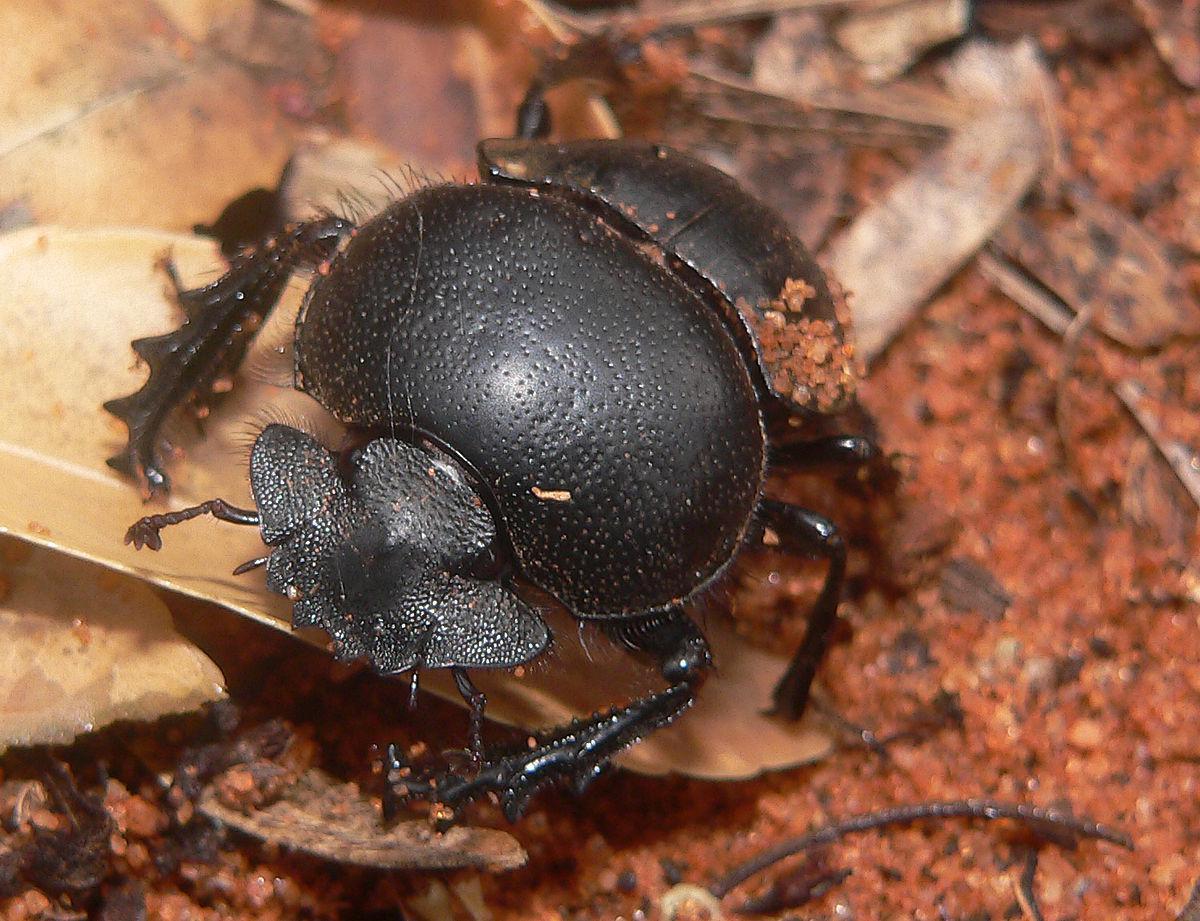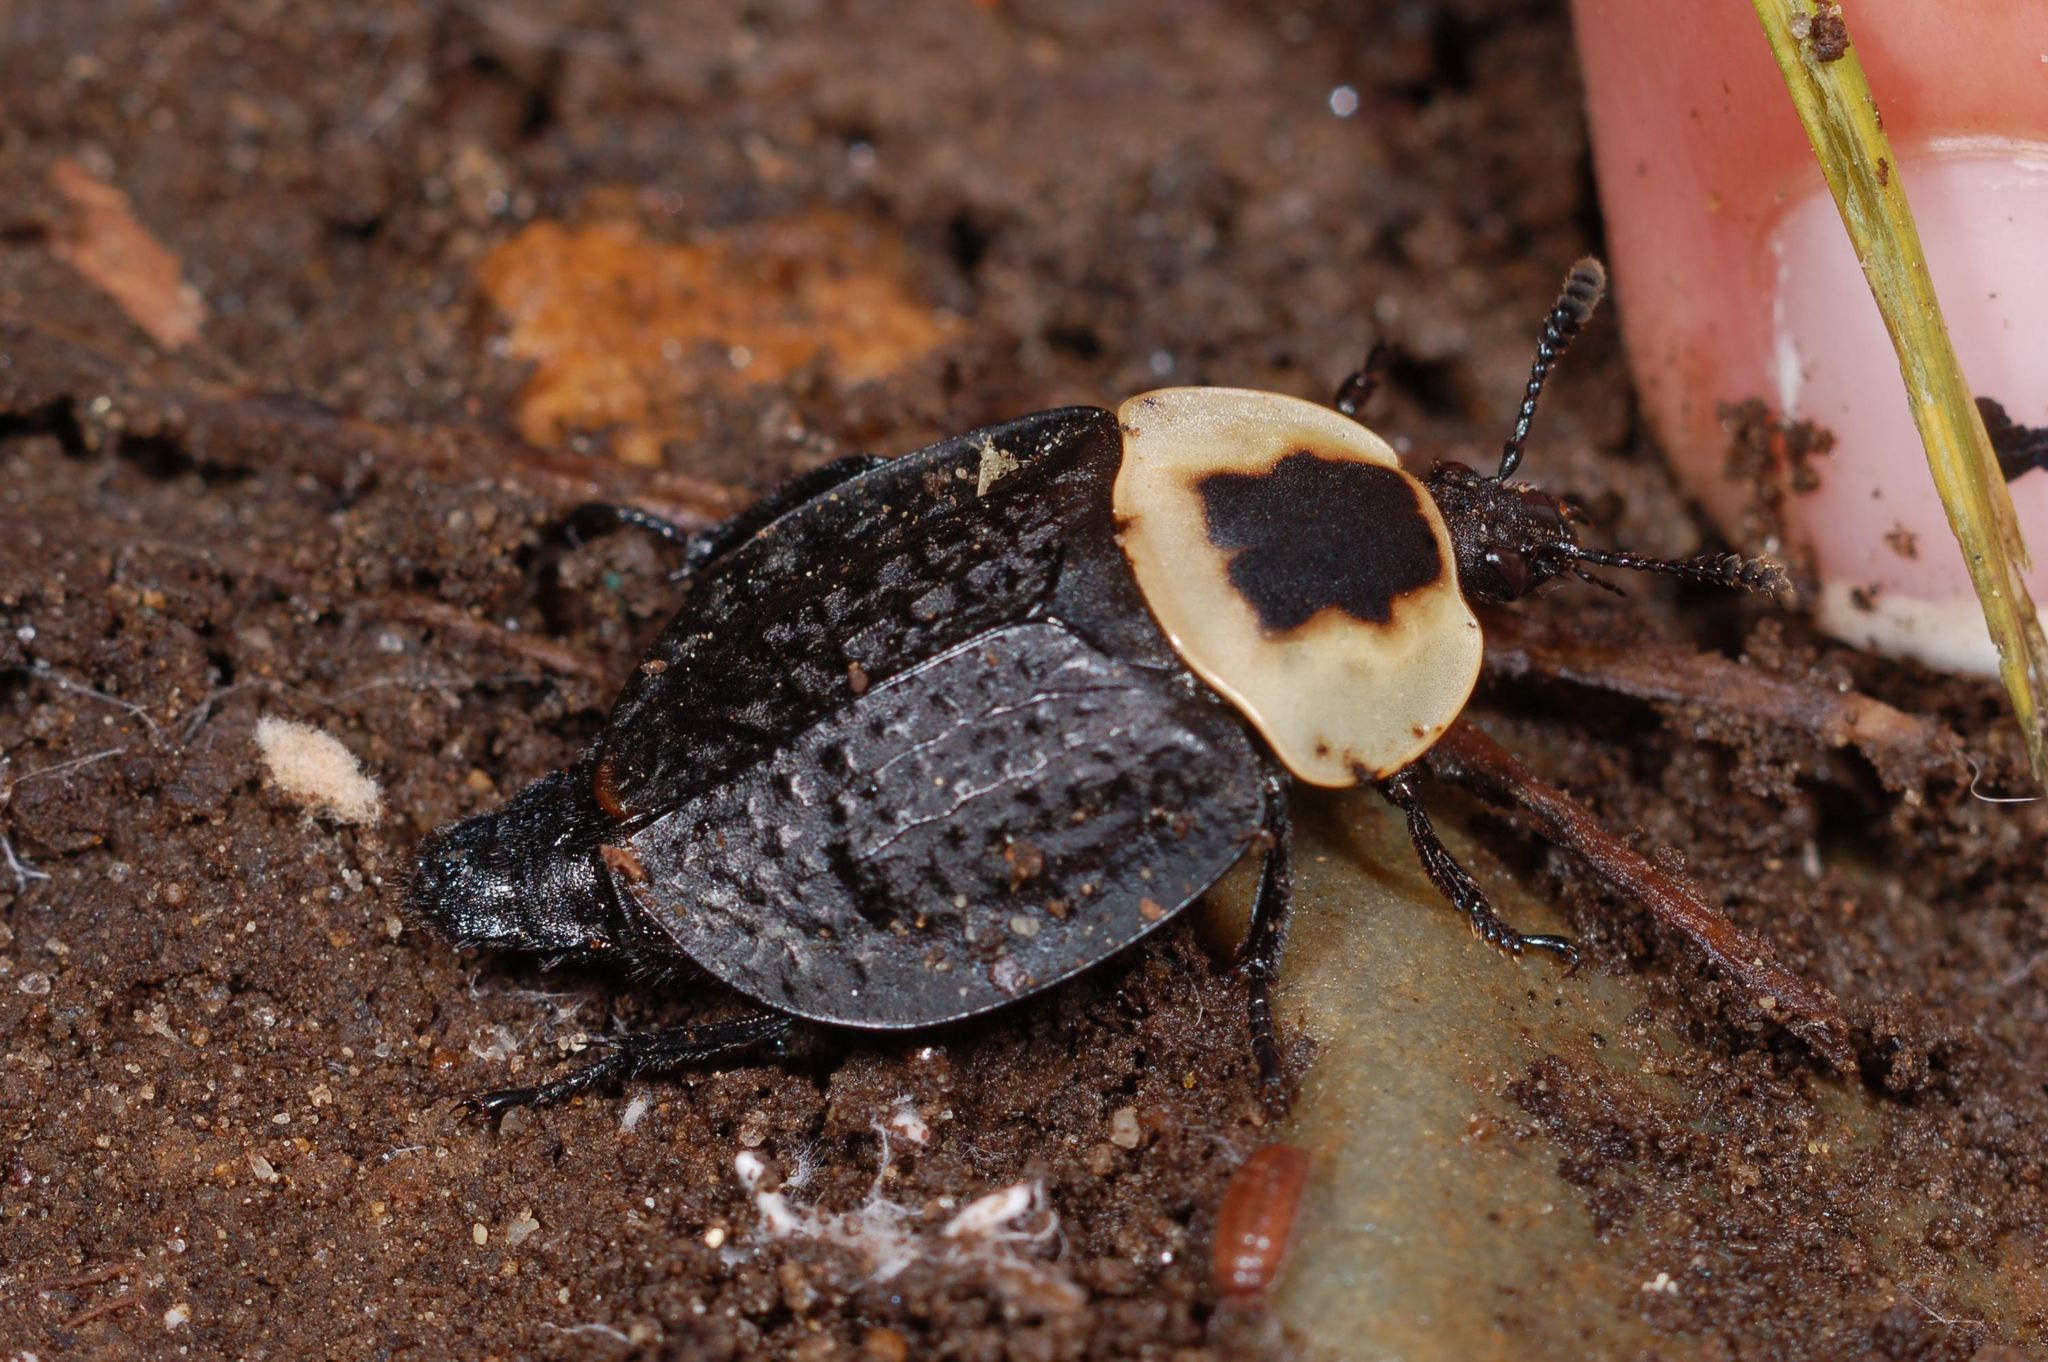The first image is the image on the left, the second image is the image on the right. Examine the images to the left and right. Is the description "There is at least one black spot on the back of the insect in one of the images." accurate? Answer yes or no. Yes. 